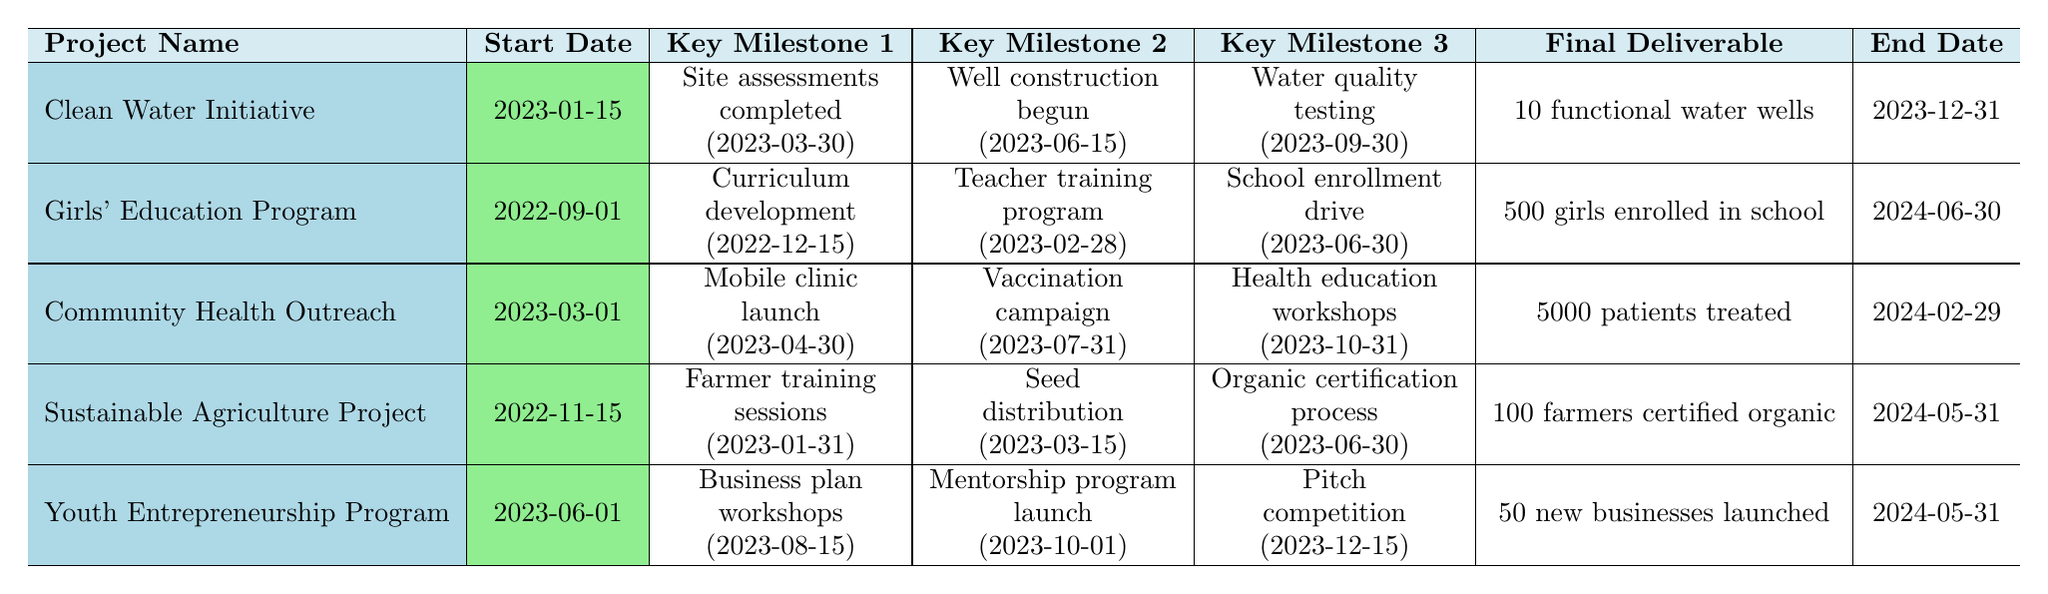What is the final deliverable for the Community Health Outreach project? The table indicates that the final deliverable for the Community Health Outreach project is "5000 patients treated."
Answer: 5000 patients treated What is the start date of the Girls' Education Program? From the table, the start date of the Girls' Education Program is listed as "2022-09-01."
Answer: 2022-09-01 How many projects have their final deliverables related to education? The table shows that two projects are related to education: "Girls' Education Program" and "Community Health Outreach." Therefore, the count is 2.
Answer: 2 What is the duration of the Clean Water Initiative project? The start date is "2023-01-15," and the end date is "2023-12-31." Counting from January 15 to December 31 gives a duration of 11.5 months.
Answer: 11.5 months Is the Youth Entrepreneurship Program set to end before the Girls' Education Program? The end date for the Youth Entrepreneurship Program is "2024-05-31," and for the Girls' Education Program it is "2024-06-30." Since May 31 is before June 30, the Youth Entrepreneurship Program ends earlier.
Answer: Yes Which project has the highest budget? By comparing the budgets listed in the table, the Community Health Outreach project has the highest budget at $1,000,000.
Answer: Community Health Outreach What is the total number of functional water wells planned as the final deliverable across all projects? Only the Clean Water Initiative specifies a deliverable of 10 functional water wells, while other projects have different deliverables. Thus, the total is still 10 functional water wells.
Answer: 10 functional water wells Identify the project that has both the earliest start date and the latest end date. The Girls' Education Program started on "2022-09-01" which is the earliest, and ends on "2024-06-30," which is the latest among the given projects.
Answer: Girls' Education Program What is the key milestone date for the Seed Distribution in the Sustainable Agriculture Project? The key milestone for Seed Distribution is scheduled for "2023-03-15" as per the table.
Answer: 2023-03-15 Which two projects have key milestones in April 2023? The Clean Water Initiative has its key milestone "Well construction begun" on "2023-06-15" and "Mobile clinic launch" for Community Health Outreach on "2023-04-30," making those the two projects with milestones in April.
Answer: Clean Water Initiative and Community Health Outreach 